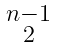Convert formula to latex. <formula><loc_0><loc_0><loc_500><loc_500>\begin{smallmatrix} n - 1 \\ 2 \end{smallmatrix}</formula> 